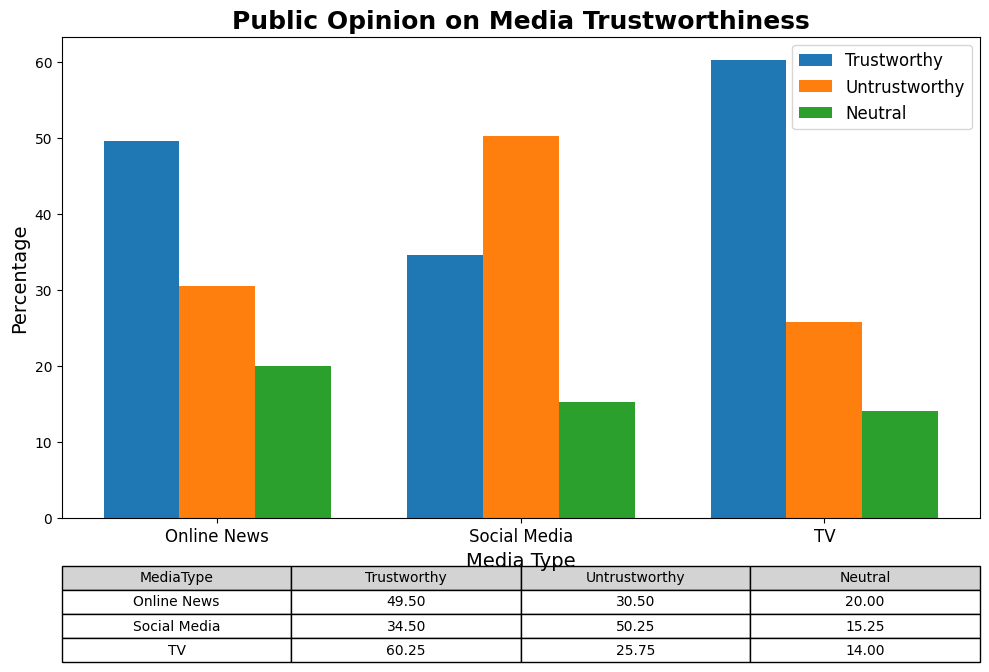What is the average percentage of people who find Social Media trustworthy? To find the average percentage for Social Media's trustworthiness, add all the trust percentages for Social Media from the data (35, 33, 34, 36) and divide by the number of data points (4). (35 + 33 + 34 + 36) / 4 = 34.5
Answer: 34.5 Between TV and Online News, which one has a higher average percentage of people who find it untrustworthy? Calculate the average untrustworthy percentage for TV and Online News. For TV: (25 + 24 + 28 + 26) / 4 = 25.75. For Online News: (30 + 32 + 29 + 31) / 4 = 30.5. Compare the results: 30.5 is higher than 25.75.
Answer: Online News What is the difference in the average percentage of people who found TV trustworthy versus neutral? Calculate the average trustworthy and neutral percentages for TV from the data. Trustworthy: (60 + 62 + 58 + 61) / 4 = 60.25. Neutral: (15 + 14 + 14 + 13) / 4 = 14.0. Subtract the neutral average from the trustworthy average: 60.25 - 14.0 = 46.25
Answer: 46.25 Which media type has the largest range in untrustworthy percentages? Calculate the range (max - min) of untrustworthy percentages for each media type. TV: max(28) - min(24) = 4, Online News: max(32) - min(29) = 3, Social Media: max(52) - min(48) = 4. Both TV and Social Media have a range of 4.
Answer: TV and Social Media In terms of neutral percentages, which media type has the lowest average and what is it? Calculate the average neutral percentage for each media type. TV: (15 + 14 + 14 + 13) / 4 = 14.0, Online News: (20 + 20 + 20 + 20) / 4 = 20.0, Social Media: (15 + 15 + 15 + 16) / 4 = 15.25. The lowest average neutral percentage is for TV, which is 14.0.
Answer: TV, 14.0 By how much does the average trustworthy percentage for Online News exceed that for Social Media? Compute the average trustworthy percentage for Online News and Social Media. Online News: (50 + 48 + 51 + 49) / 4 = 49.5. Social Media: (35 + 33 + 34 + 36) / 4 = 34.5. Subtract the Social Media average from the Online News average: 49.5 - 34.5 = 15.0
Answer: 15.0 Which media type has the highest average percentage of people who are neutral towards it? Calculate the average neutral percentage for each media type. TV: (15 + 14 + 14 + 13) / 4 = 14.0, Online News: (20 + 20 + 20 + 20) / 4 = 20.0, Social Media: (15 + 15 + 15 + 16) / 4 = 15.25. Online News has the highest average neutral percentage of 20.0
Answer: Online News 